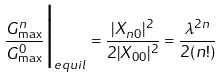Convert formula to latex. <formula><loc_0><loc_0><loc_500><loc_500>\frac { G _ { \max } ^ { n } } { G _ { \max } ^ { 0 } } \Big | _ { e q u i l } = \frac { | X _ { n 0 } | ^ { 2 } } { 2 | X _ { 0 0 } | ^ { 2 } } = \frac { \lambda ^ { 2 n } } { 2 ( n ! ) }</formula> 